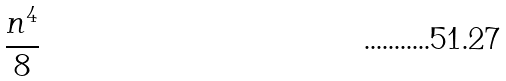Convert formula to latex. <formula><loc_0><loc_0><loc_500><loc_500>\frac { n ^ { 4 } } { 8 }</formula> 